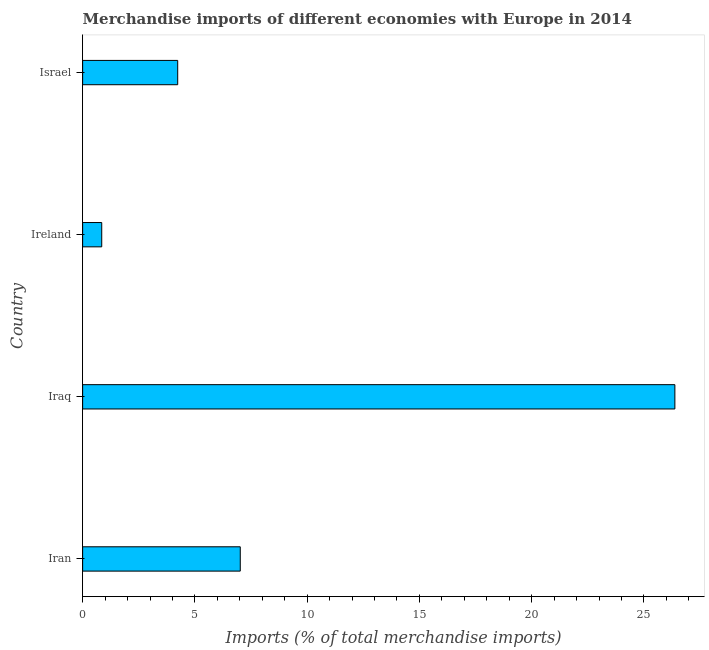Does the graph contain any zero values?
Provide a succinct answer. No. Does the graph contain grids?
Offer a terse response. No. What is the title of the graph?
Your answer should be compact. Merchandise imports of different economies with Europe in 2014. What is the label or title of the X-axis?
Your response must be concise. Imports (% of total merchandise imports). What is the label or title of the Y-axis?
Provide a succinct answer. Country. What is the merchandise imports in Iraq?
Provide a short and direct response. 26.38. Across all countries, what is the maximum merchandise imports?
Your response must be concise. 26.38. Across all countries, what is the minimum merchandise imports?
Offer a terse response. 0.85. In which country was the merchandise imports maximum?
Your response must be concise. Iraq. In which country was the merchandise imports minimum?
Keep it short and to the point. Ireland. What is the sum of the merchandise imports?
Offer a terse response. 38.48. What is the difference between the merchandise imports in Iran and Israel?
Offer a terse response. 2.79. What is the average merchandise imports per country?
Keep it short and to the point. 9.62. What is the median merchandise imports?
Your response must be concise. 5.63. What is the ratio of the merchandise imports in Iran to that in Iraq?
Your answer should be very brief. 0.27. Is the merchandise imports in Iran less than that in Israel?
Keep it short and to the point. No. What is the difference between the highest and the second highest merchandise imports?
Your response must be concise. 19.36. What is the difference between the highest and the lowest merchandise imports?
Keep it short and to the point. 25.53. How many bars are there?
Offer a terse response. 4. Are all the bars in the graph horizontal?
Ensure brevity in your answer.  Yes. How many countries are there in the graph?
Your answer should be compact. 4. What is the difference between two consecutive major ticks on the X-axis?
Ensure brevity in your answer.  5. What is the Imports (% of total merchandise imports) in Iran?
Your answer should be very brief. 7.02. What is the Imports (% of total merchandise imports) of Iraq?
Provide a succinct answer. 26.38. What is the Imports (% of total merchandise imports) of Ireland?
Your answer should be compact. 0.85. What is the Imports (% of total merchandise imports) of Israel?
Your answer should be compact. 4.23. What is the difference between the Imports (% of total merchandise imports) in Iran and Iraq?
Give a very brief answer. -19.36. What is the difference between the Imports (% of total merchandise imports) in Iran and Ireland?
Provide a succinct answer. 6.17. What is the difference between the Imports (% of total merchandise imports) in Iran and Israel?
Provide a succinct answer. 2.79. What is the difference between the Imports (% of total merchandise imports) in Iraq and Ireland?
Keep it short and to the point. 25.53. What is the difference between the Imports (% of total merchandise imports) in Iraq and Israel?
Provide a succinct answer. 22.14. What is the difference between the Imports (% of total merchandise imports) in Ireland and Israel?
Offer a terse response. -3.38. What is the ratio of the Imports (% of total merchandise imports) in Iran to that in Iraq?
Your response must be concise. 0.27. What is the ratio of the Imports (% of total merchandise imports) in Iran to that in Ireland?
Make the answer very short. 8.25. What is the ratio of the Imports (% of total merchandise imports) in Iran to that in Israel?
Make the answer very short. 1.66. What is the ratio of the Imports (% of total merchandise imports) in Iraq to that in Ireland?
Give a very brief answer. 31.01. What is the ratio of the Imports (% of total merchandise imports) in Iraq to that in Israel?
Ensure brevity in your answer.  6.23. What is the ratio of the Imports (% of total merchandise imports) in Ireland to that in Israel?
Ensure brevity in your answer.  0.2. 